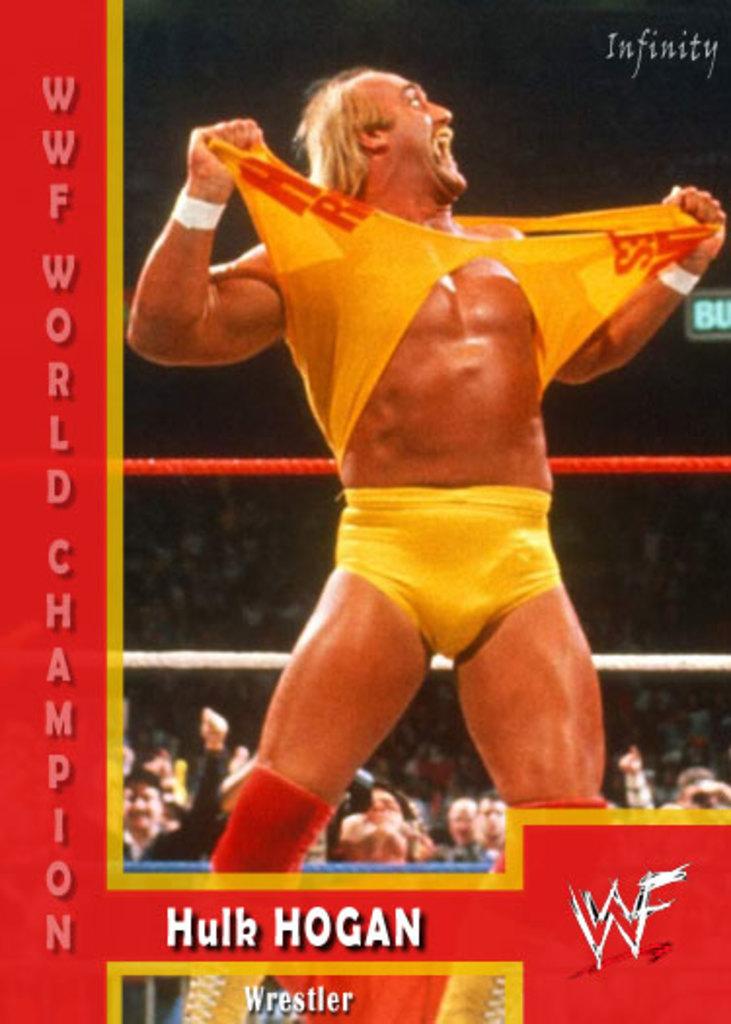Who is that man in the yellow shirt?
Your answer should be very brief. Hulk hogan. What is hulk hogan's occupation?
Your response must be concise. Wrestler. 